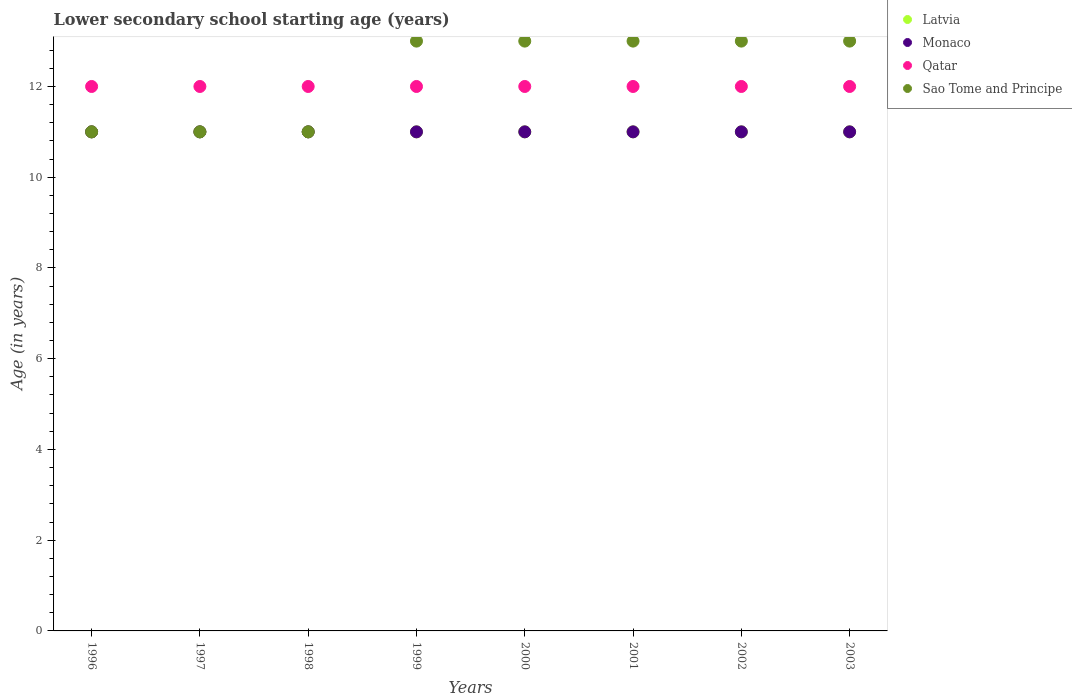How many different coloured dotlines are there?
Offer a very short reply. 4. Is the number of dotlines equal to the number of legend labels?
Provide a succinct answer. Yes. What is the lower secondary school starting age of children in Monaco in 1999?
Make the answer very short. 11. Across all years, what is the maximum lower secondary school starting age of children in Sao Tome and Principe?
Provide a succinct answer. 13. Across all years, what is the minimum lower secondary school starting age of children in Qatar?
Offer a very short reply. 12. What is the total lower secondary school starting age of children in Qatar in the graph?
Your answer should be very brief. 96. What is the difference between the lower secondary school starting age of children in Qatar in 1998 and the lower secondary school starting age of children in Sao Tome and Principe in 2002?
Ensure brevity in your answer.  -1. In the year 2002, what is the difference between the lower secondary school starting age of children in Latvia and lower secondary school starting age of children in Sao Tome and Principe?
Your answer should be compact. -2. In how many years, is the lower secondary school starting age of children in Qatar greater than 9.2 years?
Offer a very short reply. 8. Is the lower secondary school starting age of children in Qatar in 1996 less than that in 2003?
Provide a succinct answer. No. Is the difference between the lower secondary school starting age of children in Latvia in 1997 and 2001 greater than the difference between the lower secondary school starting age of children in Sao Tome and Principe in 1997 and 2001?
Offer a terse response. Yes. What is the difference between the highest and the lowest lower secondary school starting age of children in Qatar?
Your answer should be compact. 0. Is it the case that in every year, the sum of the lower secondary school starting age of children in Sao Tome and Principe and lower secondary school starting age of children in Qatar  is greater than the lower secondary school starting age of children in Monaco?
Make the answer very short. Yes. Does the lower secondary school starting age of children in Latvia monotonically increase over the years?
Ensure brevity in your answer.  No. How many dotlines are there?
Provide a short and direct response. 4. Does the graph contain any zero values?
Provide a short and direct response. No. Where does the legend appear in the graph?
Give a very brief answer. Top right. What is the title of the graph?
Provide a short and direct response. Lower secondary school starting age (years). Does "Canada" appear as one of the legend labels in the graph?
Provide a short and direct response. No. What is the label or title of the Y-axis?
Give a very brief answer. Age (in years). What is the Age (in years) of Latvia in 1996?
Keep it short and to the point. 11. What is the Age (in years) of Qatar in 1996?
Keep it short and to the point. 12. What is the Age (in years) of Sao Tome and Principe in 1996?
Your answer should be very brief. 11. What is the Age (in years) in Latvia in 1998?
Provide a succinct answer. 11. What is the Age (in years) of Monaco in 1998?
Ensure brevity in your answer.  11. What is the Age (in years) in Qatar in 1998?
Your answer should be compact. 12. What is the Age (in years) in Sao Tome and Principe in 1998?
Make the answer very short. 11. What is the Age (in years) in Sao Tome and Principe in 1999?
Keep it short and to the point. 13. What is the Age (in years) in Latvia in 2000?
Keep it short and to the point. 11. What is the Age (in years) of Monaco in 2000?
Make the answer very short. 11. What is the Age (in years) of Latvia in 2001?
Make the answer very short. 11. What is the Age (in years) of Latvia in 2002?
Make the answer very short. 11. What is the Age (in years) of Qatar in 2002?
Your response must be concise. 12. What is the Age (in years) of Monaco in 2003?
Your response must be concise. 11. What is the Age (in years) of Qatar in 2003?
Your answer should be compact. 12. What is the Age (in years) in Sao Tome and Principe in 2003?
Make the answer very short. 13. Across all years, what is the maximum Age (in years) of Monaco?
Give a very brief answer. 11. Across all years, what is the minimum Age (in years) in Latvia?
Make the answer very short. 11. Across all years, what is the minimum Age (in years) of Qatar?
Provide a short and direct response. 12. What is the total Age (in years) of Monaco in the graph?
Keep it short and to the point. 88. What is the total Age (in years) of Qatar in the graph?
Your response must be concise. 96. What is the total Age (in years) in Sao Tome and Principe in the graph?
Offer a terse response. 98. What is the difference between the Age (in years) of Monaco in 1996 and that in 1997?
Your response must be concise. 0. What is the difference between the Age (in years) of Qatar in 1996 and that in 1997?
Provide a short and direct response. 0. What is the difference between the Age (in years) in Monaco in 1996 and that in 1998?
Make the answer very short. 0. What is the difference between the Age (in years) in Qatar in 1996 and that in 1998?
Your answer should be compact. 0. What is the difference between the Age (in years) in Sao Tome and Principe in 1996 and that in 1998?
Offer a terse response. 0. What is the difference between the Age (in years) in Latvia in 1996 and that in 1999?
Provide a succinct answer. 0. What is the difference between the Age (in years) in Latvia in 1996 and that in 2000?
Your answer should be compact. 0. What is the difference between the Age (in years) in Qatar in 1996 and that in 2000?
Provide a succinct answer. 0. What is the difference between the Age (in years) in Qatar in 1996 and that in 2001?
Offer a terse response. 0. What is the difference between the Age (in years) in Sao Tome and Principe in 1996 and that in 2001?
Provide a succinct answer. -2. What is the difference between the Age (in years) in Monaco in 1996 and that in 2002?
Your answer should be compact. 0. What is the difference between the Age (in years) in Qatar in 1996 and that in 2002?
Keep it short and to the point. 0. What is the difference between the Age (in years) of Sao Tome and Principe in 1996 and that in 2002?
Offer a terse response. -2. What is the difference between the Age (in years) of Monaco in 1996 and that in 2003?
Provide a short and direct response. 0. What is the difference between the Age (in years) in Qatar in 1996 and that in 2003?
Make the answer very short. 0. What is the difference between the Age (in years) of Latvia in 1997 and that in 1998?
Offer a terse response. 0. What is the difference between the Age (in years) of Qatar in 1997 and that in 1998?
Provide a short and direct response. 0. What is the difference between the Age (in years) in Sao Tome and Principe in 1997 and that in 1999?
Your response must be concise. -2. What is the difference between the Age (in years) in Latvia in 1997 and that in 2000?
Your answer should be very brief. 0. What is the difference between the Age (in years) of Monaco in 1997 and that in 2000?
Provide a succinct answer. 0. What is the difference between the Age (in years) of Qatar in 1997 and that in 2000?
Keep it short and to the point. 0. What is the difference between the Age (in years) of Sao Tome and Principe in 1997 and that in 2000?
Your response must be concise. -2. What is the difference between the Age (in years) in Latvia in 1997 and that in 2001?
Provide a succinct answer. 0. What is the difference between the Age (in years) of Sao Tome and Principe in 1997 and that in 2001?
Your response must be concise. -2. What is the difference between the Age (in years) in Latvia in 1997 and that in 2002?
Your answer should be compact. 0. What is the difference between the Age (in years) of Monaco in 1997 and that in 2002?
Keep it short and to the point. 0. What is the difference between the Age (in years) in Qatar in 1997 and that in 2002?
Give a very brief answer. 0. What is the difference between the Age (in years) of Sao Tome and Principe in 1997 and that in 2002?
Give a very brief answer. -2. What is the difference between the Age (in years) of Qatar in 1997 and that in 2003?
Your answer should be very brief. 0. What is the difference between the Age (in years) in Sao Tome and Principe in 1998 and that in 1999?
Provide a succinct answer. -2. What is the difference between the Age (in years) in Sao Tome and Principe in 1998 and that in 2000?
Give a very brief answer. -2. What is the difference between the Age (in years) of Latvia in 1998 and that in 2002?
Make the answer very short. 0. What is the difference between the Age (in years) in Monaco in 1998 and that in 2002?
Provide a short and direct response. 0. What is the difference between the Age (in years) in Monaco in 1998 and that in 2003?
Provide a short and direct response. 0. What is the difference between the Age (in years) of Sao Tome and Principe in 1998 and that in 2003?
Your answer should be compact. -2. What is the difference between the Age (in years) in Monaco in 1999 and that in 2000?
Make the answer very short. 0. What is the difference between the Age (in years) of Qatar in 1999 and that in 2001?
Ensure brevity in your answer.  0. What is the difference between the Age (in years) in Sao Tome and Principe in 1999 and that in 2001?
Offer a very short reply. 0. What is the difference between the Age (in years) of Latvia in 1999 and that in 2002?
Provide a succinct answer. 0. What is the difference between the Age (in years) of Sao Tome and Principe in 1999 and that in 2002?
Your answer should be compact. 0. What is the difference between the Age (in years) in Qatar in 1999 and that in 2003?
Provide a short and direct response. 0. What is the difference between the Age (in years) of Sao Tome and Principe in 1999 and that in 2003?
Keep it short and to the point. 0. What is the difference between the Age (in years) in Sao Tome and Principe in 2000 and that in 2001?
Your response must be concise. 0. What is the difference between the Age (in years) of Latvia in 2000 and that in 2002?
Offer a terse response. 0. What is the difference between the Age (in years) in Sao Tome and Principe in 2000 and that in 2002?
Offer a terse response. 0. What is the difference between the Age (in years) of Latvia in 2000 and that in 2003?
Your answer should be compact. 0. What is the difference between the Age (in years) in Monaco in 2000 and that in 2003?
Provide a succinct answer. 0. What is the difference between the Age (in years) in Qatar in 2000 and that in 2003?
Keep it short and to the point. 0. What is the difference between the Age (in years) of Sao Tome and Principe in 2000 and that in 2003?
Keep it short and to the point. 0. What is the difference between the Age (in years) of Latvia in 2001 and that in 2002?
Your answer should be compact. 0. What is the difference between the Age (in years) of Monaco in 2001 and that in 2002?
Offer a terse response. 0. What is the difference between the Age (in years) of Qatar in 2001 and that in 2002?
Ensure brevity in your answer.  0. What is the difference between the Age (in years) of Monaco in 2001 and that in 2003?
Keep it short and to the point. 0. What is the difference between the Age (in years) in Sao Tome and Principe in 2001 and that in 2003?
Your answer should be very brief. 0. What is the difference between the Age (in years) in Latvia in 2002 and that in 2003?
Provide a short and direct response. 0. What is the difference between the Age (in years) in Sao Tome and Principe in 2002 and that in 2003?
Keep it short and to the point. 0. What is the difference between the Age (in years) of Latvia in 1996 and the Age (in years) of Monaco in 1997?
Offer a terse response. 0. What is the difference between the Age (in years) of Monaco in 1996 and the Age (in years) of Sao Tome and Principe in 1997?
Keep it short and to the point. 0. What is the difference between the Age (in years) of Qatar in 1996 and the Age (in years) of Sao Tome and Principe in 1997?
Offer a terse response. 1. What is the difference between the Age (in years) in Latvia in 1996 and the Age (in years) in Sao Tome and Principe in 1998?
Make the answer very short. 0. What is the difference between the Age (in years) in Latvia in 1996 and the Age (in years) in Qatar in 1999?
Your response must be concise. -1. What is the difference between the Age (in years) of Latvia in 1996 and the Age (in years) of Sao Tome and Principe in 1999?
Make the answer very short. -2. What is the difference between the Age (in years) in Monaco in 1996 and the Age (in years) in Qatar in 1999?
Your response must be concise. -1. What is the difference between the Age (in years) in Latvia in 1996 and the Age (in years) in Monaco in 2000?
Your response must be concise. 0. What is the difference between the Age (in years) in Monaco in 1996 and the Age (in years) in Qatar in 2000?
Your answer should be very brief. -1. What is the difference between the Age (in years) of Qatar in 1996 and the Age (in years) of Sao Tome and Principe in 2000?
Make the answer very short. -1. What is the difference between the Age (in years) in Latvia in 1996 and the Age (in years) in Monaco in 2001?
Your answer should be very brief. 0. What is the difference between the Age (in years) of Latvia in 1996 and the Age (in years) of Monaco in 2002?
Offer a terse response. 0. What is the difference between the Age (in years) in Latvia in 1996 and the Age (in years) in Sao Tome and Principe in 2002?
Make the answer very short. -2. What is the difference between the Age (in years) of Qatar in 1996 and the Age (in years) of Sao Tome and Principe in 2002?
Offer a very short reply. -1. What is the difference between the Age (in years) of Latvia in 1996 and the Age (in years) of Qatar in 2003?
Offer a very short reply. -1. What is the difference between the Age (in years) of Latvia in 1996 and the Age (in years) of Sao Tome and Principe in 2003?
Offer a terse response. -2. What is the difference between the Age (in years) in Monaco in 1996 and the Age (in years) in Qatar in 2003?
Offer a terse response. -1. What is the difference between the Age (in years) in Monaco in 1996 and the Age (in years) in Sao Tome and Principe in 2003?
Provide a succinct answer. -2. What is the difference between the Age (in years) of Qatar in 1996 and the Age (in years) of Sao Tome and Principe in 2003?
Ensure brevity in your answer.  -1. What is the difference between the Age (in years) of Latvia in 1997 and the Age (in years) of Monaco in 1998?
Your answer should be compact. 0. What is the difference between the Age (in years) in Monaco in 1997 and the Age (in years) in Qatar in 1999?
Make the answer very short. -1. What is the difference between the Age (in years) of Monaco in 1997 and the Age (in years) of Sao Tome and Principe in 1999?
Your response must be concise. -2. What is the difference between the Age (in years) in Latvia in 1997 and the Age (in years) in Sao Tome and Principe in 2000?
Provide a succinct answer. -2. What is the difference between the Age (in years) in Latvia in 1997 and the Age (in years) in Monaco in 2001?
Make the answer very short. 0. What is the difference between the Age (in years) of Latvia in 1997 and the Age (in years) of Qatar in 2001?
Make the answer very short. -1. What is the difference between the Age (in years) of Latvia in 1997 and the Age (in years) of Sao Tome and Principe in 2001?
Provide a short and direct response. -2. What is the difference between the Age (in years) of Latvia in 1997 and the Age (in years) of Monaco in 2002?
Offer a terse response. 0. What is the difference between the Age (in years) of Latvia in 1997 and the Age (in years) of Sao Tome and Principe in 2002?
Offer a terse response. -2. What is the difference between the Age (in years) in Monaco in 1997 and the Age (in years) in Qatar in 2002?
Your response must be concise. -1. What is the difference between the Age (in years) in Latvia in 1997 and the Age (in years) in Monaco in 2003?
Offer a very short reply. 0. What is the difference between the Age (in years) of Latvia in 1997 and the Age (in years) of Qatar in 2003?
Ensure brevity in your answer.  -1. What is the difference between the Age (in years) in Latvia in 1997 and the Age (in years) in Sao Tome and Principe in 2003?
Offer a terse response. -2. What is the difference between the Age (in years) of Monaco in 1997 and the Age (in years) of Qatar in 2003?
Your response must be concise. -1. What is the difference between the Age (in years) in Latvia in 1998 and the Age (in years) in Monaco in 1999?
Provide a short and direct response. 0. What is the difference between the Age (in years) in Latvia in 1998 and the Age (in years) in Sao Tome and Principe in 1999?
Your response must be concise. -2. What is the difference between the Age (in years) in Monaco in 1998 and the Age (in years) in Qatar in 1999?
Keep it short and to the point. -1. What is the difference between the Age (in years) in Monaco in 1998 and the Age (in years) in Sao Tome and Principe in 1999?
Ensure brevity in your answer.  -2. What is the difference between the Age (in years) of Qatar in 1998 and the Age (in years) of Sao Tome and Principe in 1999?
Your answer should be very brief. -1. What is the difference between the Age (in years) in Latvia in 1998 and the Age (in years) in Monaco in 2000?
Your response must be concise. 0. What is the difference between the Age (in years) of Latvia in 1998 and the Age (in years) of Qatar in 2000?
Keep it short and to the point. -1. What is the difference between the Age (in years) in Latvia in 1998 and the Age (in years) in Sao Tome and Principe in 2000?
Your answer should be very brief. -2. What is the difference between the Age (in years) in Monaco in 1998 and the Age (in years) in Sao Tome and Principe in 2000?
Your answer should be compact. -2. What is the difference between the Age (in years) in Latvia in 1998 and the Age (in years) in Qatar in 2001?
Provide a short and direct response. -1. What is the difference between the Age (in years) of Monaco in 1998 and the Age (in years) of Qatar in 2001?
Make the answer very short. -1. What is the difference between the Age (in years) in Qatar in 1998 and the Age (in years) in Sao Tome and Principe in 2001?
Give a very brief answer. -1. What is the difference between the Age (in years) of Latvia in 1998 and the Age (in years) of Monaco in 2002?
Offer a terse response. 0. What is the difference between the Age (in years) of Latvia in 1998 and the Age (in years) of Sao Tome and Principe in 2002?
Offer a very short reply. -2. What is the difference between the Age (in years) in Qatar in 1998 and the Age (in years) in Sao Tome and Principe in 2002?
Ensure brevity in your answer.  -1. What is the difference between the Age (in years) in Latvia in 1998 and the Age (in years) in Qatar in 2003?
Your answer should be very brief. -1. What is the difference between the Age (in years) in Latvia in 1998 and the Age (in years) in Sao Tome and Principe in 2003?
Offer a very short reply. -2. What is the difference between the Age (in years) of Monaco in 1998 and the Age (in years) of Qatar in 2003?
Your answer should be very brief. -1. What is the difference between the Age (in years) in Latvia in 1999 and the Age (in years) in Monaco in 2000?
Provide a succinct answer. 0. What is the difference between the Age (in years) of Latvia in 1999 and the Age (in years) of Qatar in 2000?
Offer a terse response. -1. What is the difference between the Age (in years) of Monaco in 1999 and the Age (in years) of Sao Tome and Principe in 2000?
Offer a very short reply. -2. What is the difference between the Age (in years) in Qatar in 1999 and the Age (in years) in Sao Tome and Principe in 2000?
Your answer should be compact. -1. What is the difference between the Age (in years) of Latvia in 1999 and the Age (in years) of Monaco in 2001?
Provide a succinct answer. 0. What is the difference between the Age (in years) in Monaco in 1999 and the Age (in years) in Sao Tome and Principe in 2001?
Make the answer very short. -2. What is the difference between the Age (in years) of Qatar in 1999 and the Age (in years) of Sao Tome and Principe in 2002?
Provide a short and direct response. -1. What is the difference between the Age (in years) in Latvia in 1999 and the Age (in years) in Sao Tome and Principe in 2003?
Offer a terse response. -2. What is the difference between the Age (in years) in Monaco in 1999 and the Age (in years) in Qatar in 2003?
Make the answer very short. -1. What is the difference between the Age (in years) in Latvia in 2000 and the Age (in years) in Sao Tome and Principe in 2001?
Provide a short and direct response. -2. What is the difference between the Age (in years) of Latvia in 2000 and the Age (in years) of Monaco in 2002?
Keep it short and to the point. 0. What is the difference between the Age (in years) in Monaco in 2000 and the Age (in years) in Qatar in 2002?
Offer a terse response. -1. What is the difference between the Age (in years) in Qatar in 2000 and the Age (in years) in Sao Tome and Principe in 2002?
Your answer should be compact. -1. What is the difference between the Age (in years) of Latvia in 2000 and the Age (in years) of Qatar in 2003?
Make the answer very short. -1. What is the difference between the Age (in years) in Latvia in 2000 and the Age (in years) in Sao Tome and Principe in 2003?
Offer a very short reply. -2. What is the difference between the Age (in years) of Monaco in 2000 and the Age (in years) of Sao Tome and Principe in 2003?
Offer a very short reply. -2. What is the difference between the Age (in years) in Qatar in 2000 and the Age (in years) in Sao Tome and Principe in 2003?
Ensure brevity in your answer.  -1. What is the difference between the Age (in years) in Latvia in 2001 and the Age (in years) in Qatar in 2002?
Ensure brevity in your answer.  -1. What is the difference between the Age (in years) in Monaco in 2001 and the Age (in years) in Qatar in 2002?
Keep it short and to the point. -1. What is the difference between the Age (in years) in Qatar in 2001 and the Age (in years) in Sao Tome and Principe in 2002?
Keep it short and to the point. -1. What is the difference between the Age (in years) in Latvia in 2002 and the Age (in years) in Monaco in 2003?
Provide a short and direct response. 0. What is the difference between the Age (in years) in Latvia in 2002 and the Age (in years) in Sao Tome and Principe in 2003?
Provide a succinct answer. -2. What is the difference between the Age (in years) in Monaco in 2002 and the Age (in years) in Sao Tome and Principe in 2003?
Provide a short and direct response. -2. What is the average Age (in years) in Monaco per year?
Provide a succinct answer. 11. What is the average Age (in years) of Qatar per year?
Keep it short and to the point. 12. What is the average Age (in years) in Sao Tome and Principe per year?
Keep it short and to the point. 12.25. In the year 1996, what is the difference between the Age (in years) of Latvia and Age (in years) of Monaco?
Give a very brief answer. 0. In the year 1996, what is the difference between the Age (in years) in Latvia and Age (in years) in Sao Tome and Principe?
Your answer should be very brief. 0. In the year 1996, what is the difference between the Age (in years) in Monaco and Age (in years) in Qatar?
Ensure brevity in your answer.  -1. In the year 1997, what is the difference between the Age (in years) of Latvia and Age (in years) of Qatar?
Ensure brevity in your answer.  -1. In the year 1997, what is the difference between the Age (in years) of Monaco and Age (in years) of Qatar?
Your answer should be very brief. -1. In the year 1997, what is the difference between the Age (in years) in Qatar and Age (in years) in Sao Tome and Principe?
Provide a short and direct response. 1. In the year 1998, what is the difference between the Age (in years) in Latvia and Age (in years) in Monaco?
Offer a very short reply. 0. In the year 1998, what is the difference between the Age (in years) in Latvia and Age (in years) in Qatar?
Provide a succinct answer. -1. In the year 1998, what is the difference between the Age (in years) of Latvia and Age (in years) of Sao Tome and Principe?
Offer a terse response. 0. In the year 1999, what is the difference between the Age (in years) of Latvia and Age (in years) of Qatar?
Offer a very short reply. -1. In the year 2000, what is the difference between the Age (in years) of Latvia and Age (in years) of Sao Tome and Principe?
Ensure brevity in your answer.  -2. In the year 2000, what is the difference between the Age (in years) of Monaco and Age (in years) of Sao Tome and Principe?
Make the answer very short. -2. In the year 2000, what is the difference between the Age (in years) in Qatar and Age (in years) in Sao Tome and Principe?
Make the answer very short. -1. In the year 2001, what is the difference between the Age (in years) in Latvia and Age (in years) in Monaco?
Keep it short and to the point. 0. In the year 2001, what is the difference between the Age (in years) in Latvia and Age (in years) in Qatar?
Make the answer very short. -1. In the year 2001, what is the difference between the Age (in years) in Latvia and Age (in years) in Sao Tome and Principe?
Keep it short and to the point. -2. In the year 2001, what is the difference between the Age (in years) of Monaco and Age (in years) of Qatar?
Provide a short and direct response. -1. In the year 2001, what is the difference between the Age (in years) of Monaco and Age (in years) of Sao Tome and Principe?
Provide a short and direct response. -2. In the year 2002, what is the difference between the Age (in years) in Latvia and Age (in years) in Monaco?
Provide a succinct answer. 0. In the year 2002, what is the difference between the Age (in years) in Latvia and Age (in years) in Qatar?
Keep it short and to the point. -1. In the year 2002, what is the difference between the Age (in years) of Latvia and Age (in years) of Sao Tome and Principe?
Provide a succinct answer. -2. In the year 2002, what is the difference between the Age (in years) of Monaco and Age (in years) of Qatar?
Give a very brief answer. -1. In the year 2003, what is the difference between the Age (in years) of Latvia and Age (in years) of Monaco?
Your response must be concise. 0. In the year 2003, what is the difference between the Age (in years) in Latvia and Age (in years) in Qatar?
Your response must be concise. -1. In the year 2003, what is the difference between the Age (in years) of Monaco and Age (in years) of Qatar?
Your answer should be very brief. -1. In the year 2003, what is the difference between the Age (in years) in Qatar and Age (in years) in Sao Tome and Principe?
Ensure brevity in your answer.  -1. What is the ratio of the Age (in years) in Latvia in 1996 to that in 1997?
Your response must be concise. 1. What is the ratio of the Age (in years) of Monaco in 1996 to that in 1997?
Your answer should be compact. 1. What is the ratio of the Age (in years) in Sao Tome and Principe in 1996 to that in 1997?
Your answer should be compact. 1. What is the ratio of the Age (in years) in Latvia in 1996 to that in 1998?
Your answer should be compact. 1. What is the ratio of the Age (in years) of Monaco in 1996 to that in 1998?
Your answer should be very brief. 1. What is the ratio of the Age (in years) of Sao Tome and Principe in 1996 to that in 1999?
Make the answer very short. 0.85. What is the ratio of the Age (in years) of Monaco in 1996 to that in 2000?
Your answer should be compact. 1. What is the ratio of the Age (in years) in Sao Tome and Principe in 1996 to that in 2000?
Your answer should be compact. 0.85. What is the ratio of the Age (in years) of Monaco in 1996 to that in 2001?
Ensure brevity in your answer.  1. What is the ratio of the Age (in years) in Sao Tome and Principe in 1996 to that in 2001?
Provide a short and direct response. 0.85. What is the ratio of the Age (in years) of Monaco in 1996 to that in 2002?
Your answer should be compact. 1. What is the ratio of the Age (in years) of Sao Tome and Principe in 1996 to that in 2002?
Your answer should be very brief. 0.85. What is the ratio of the Age (in years) of Qatar in 1996 to that in 2003?
Your response must be concise. 1. What is the ratio of the Age (in years) in Sao Tome and Principe in 1996 to that in 2003?
Keep it short and to the point. 0.85. What is the ratio of the Age (in years) in Latvia in 1997 to that in 1998?
Offer a very short reply. 1. What is the ratio of the Age (in years) in Qatar in 1997 to that in 1998?
Your answer should be compact. 1. What is the ratio of the Age (in years) of Sao Tome and Principe in 1997 to that in 1998?
Keep it short and to the point. 1. What is the ratio of the Age (in years) in Qatar in 1997 to that in 1999?
Offer a terse response. 1. What is the ratio of the Age (in years) in Sao Tome and Principe in 1997 to that in 1999?
Ensure brevity in your answer.  0.85. What is the ratio of the Age (in years) of Qatar in 1997 to that in 2000?
Offer a very short reply. 1. What is the ratio of the Age (in years) in Sao Tome and Principe in 1997 to that in 2000?
Keep it short and to the point. 0.85. What is the ratio of the Age (in years) in Monaco in 1997 to that in 2001?
Keep it short and to the point. 1. What is the ratio of the Age (in years) in Sao Tome and Principe in 1997 to that in 2001?
Give a very brief answer. 0.85. What is the ratio of the Age (in years) in Latvia in 1997 to that in 2002?
Offer a terse response. 1. What is the ratio of the Age (in years) in Monaco in 1997 to that in 2002?
Your answer should be compact. 1. What is the ratio of the Age (in years) in Sao Tome and Principe in 1997 to that in 2002?
Give a very brief answer. 0.85. What is the ratio of the Age (in years) of Monaco in 1997 to that in 2003?
Provide a succinct answer. 1. What is the ratio of the Age (in years) of Qatar in 1997 to that in 2003?
Provide a short and direct response. 1. What is the ratio of the Age (in years) of Sao Tome and Principe in 1997 to that in 2003?
Offer a very short reply. 0.85. What is the ratio of the Age (in years) in Sao Tome and Principe in 1998 to that in 1999?
Provide a short and direct response. 0.85. What is the ratio of the Age (in years) of Latvia in 1998 to that in 2000?
Your answer should be very brief. 1. What is the ratio of the Age (in years) in Monaco in 1998 to that in 2000?
Offer a very short reply. 1. What is the ratio of the Age (in years) in Qatar in 1998 to that in 2000?
Provide a succinct answer. 1. What is the ratio of the Age (in years) of Sao Tome and Principe in 1998 to that in 2000?
Give a very brief answer. 0.85. What is the ratio of the Age (in years) in Latvia in 1998 to that in 2001?
Provide a short and direct response. 1. What is the ratio of the Age (in years) of Qatar in 1998 to that in 2001?
Give a very brief answer. 1. What is the ratio of the Age (in years) of Sao Tome and Principe in 1998 to that in 2001?
Ensure brevity in your answer.  0.85. What is the ratio of the Age (in years) in Latvia in 1998 to that in 2002?
Offer a very short reply. 1. What is the ratio of the Age (in years) of Sao Tome and Principe in 1998 to that in 2002?
Provide a short and direct response. 0.85. What is the ratio of the Age (in years) in Monaco in 1998 to that in 2003?
Make the answer very short. 1. What is the ratio of the Age (in years) of Qatar in 1998 to that in 2003?
Ensure brevity in your answer.  1. What is the ratio of the Age (in years) of Sao Tome and Principe in 1998 to that in 2003?
Your answer should be compact. 0.85. What is the ratio of the Age (in years) in Monaco in 1999 to that in 2000?
Give a very brief answer. 1. What is the ratio of the Age (in years) in Sao Tome and Principe in 1999 to that in 2000?
Offer a terse response. 1. What is the ratio of the Age (in years) in Latvia in 1999 to that in 2001?
Keep it short and to the point. 1. What is the ratio of the Age (in years) in Monaco in 1999 to that in 2001?
Ensure brevity in your answer.  1. What is the ratio of the Age (in years) in Monaco in 1999 to that in 2002?
Your answer should be compact. 1. What is the ratio of the Age (in years) in Monaco in 1999 to that in 2003?
Give a very brief answer. 1. What is the ratio of the Age (in years) of Latvia in 2000 to that in 2001?
Your answer should be compact. 1. What is the ratio of the Age (in years) in Monaco in 2000 to that in 2001?
Give a very brief answer. 1. What is the ratio of the Age (in years) of Qatar in 2000 to that in 2001?
Keep it short and to the point. 1. What is the ratio of the Age (in years) of Sao Tome and Principe in 2000 to that in 2001?
Your answer should be compact. 1. What is the ratio of the Age (in years) in Monaco in 2000 to that in 2002?
Your response must be concise. 1. What is the ratio of the Age (in years) in Sao Tome and Principe in 2000 to that in 2002?
Offer a very short reply. 1. What is the ratio of the Age (in years) of Latvia in 2000 to that in 2003?
Your answer should be very brief. 1. What is the ratio of the Age (in years) of Qatar in 2000 to that in 2003?
Your response must be concise. 1. What is the ratio of the Age (in years) in Qatar in 2001 to that in 2002?
Make the answer very short. 1. What is the ratio of the Age (in years) in Latvia in 2001 to that in 2003?
Your answer should be very brief. 1. What is the ratio of the Age (in years) of Qatar in 2002 to that in 2003?
Give a very brief answer. 1. What is the ratio of the Age (in years) in Sao Tome and Principe in 2002 to that in 2003?
Provide a succinct answer. 1. What is the difference between the highest and the second highest Age (in years) in Latvia?
Your answer should be compact. 0. What is the difference between the highest and the second highest Age (in years) in Monaco?
Keep it short and to the point. 0. What is the difference between the highest and the second highest Age (in years) in Qatar?
Provide a succinct answer. 0. 